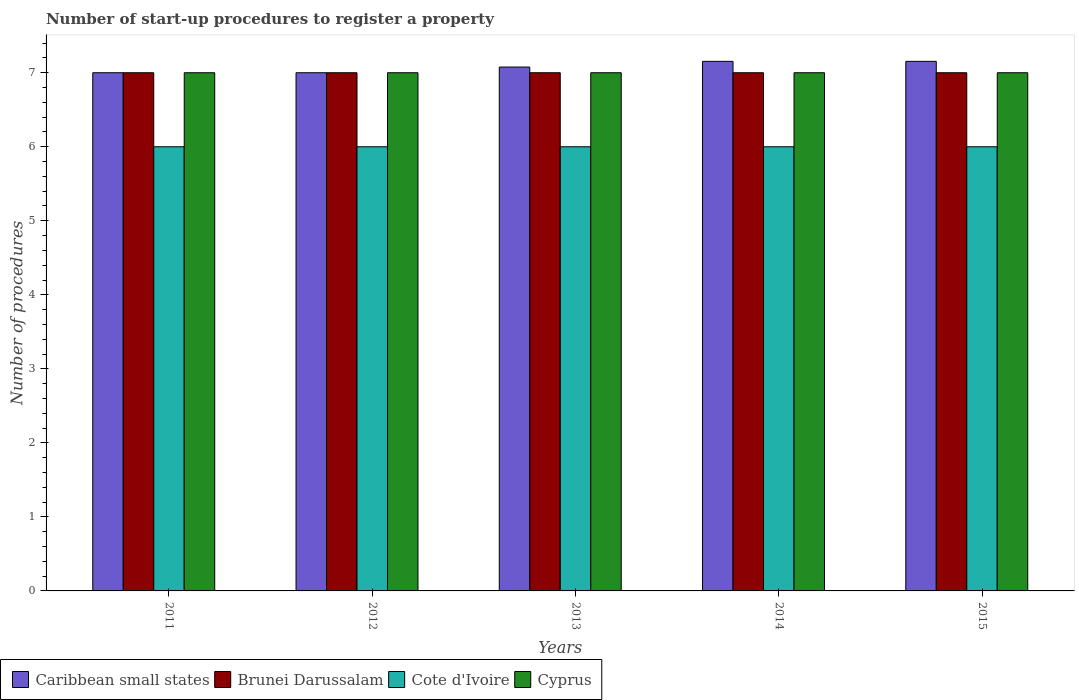How many groups of bars are there?
Ensure brevity in your answer.  5. How many bars are there on the 4th tick from the left?
Keep it short and to the point. 4. How many bars are there on the 2nd tick from the right?
Offer a terse response. 4. What is the label of the 2nd group of bars from the left?
Offer a terse response. 2012. In how many cases, is the number of bars for a given year not equal to the number of legend labels?
Your response must be concise. 0. What is the number of procedures required to register a property in Caribbean small states in 2013?
Your answer should be very brief. 7.08. Across all years, what is the minimum number of procedures required to register a property in Cote d'Ivoire?
Keep it short and to the point. 6. What is the difference between the number of procedures required to register a property in Cote d'Ivoire in 2014 and that in 2015?
Your answer should be compact. 0. In the year 2011, what is the difference between the number of procedures required to register a property in Caribbean small states and number of procedures required to register a property in Cote d'Ivoire?
Provide a succinct answer. 1. What is the ratio of the number of procedures required to register a property in Cote d'Ivoire in 2013 to that in 2014?
Provide a succinct answer. 1. Is the difference between the number of procedures required to register a property in Caribbean small states in 2014 and 2015 greater than the difference between the number of procedures required to register a property in Cote d'Ivoire in 2014 and 2015?
Your answer should be very brief. No. What is the difference between the highest and the lowest number of procedures required to register a property in Caribbean small states?
Make the answer very short. 0.15. In how many years, is the number of procedures required to register a property in Brunei Darussalam greater than the average number of procedures required to register a property in Brunei Darussalam taken over all years?
Make the answer very short. 0. Is the sum of the number of procedures required to register a property in Brunei Darussalam in 2012 and 2015 greater than the maximum number of procedures required to register a property in Cyprus across all years?
Give a very brief answer. Yes. What does the 3rd bar from the left in 2015 represents?
Your answer should be compact. Cote d'Ivoire. What does the 4th bar from the right in 2015 represents?
Your response must be concise. Caribbean small states. How many bars are there?
Make the answer very short. 20. How many years are there in the graph?
Give a very brief answer. 5. What is the difference between two consecutive major ticks on the Y-axis?
Offer a very short reply. 1. Are the values on the major ticks of Y-axis written in scientific E-notation?
Provide a succinct answer. No. Does the graph contain grids?
Provide a succinct answer. No. Where does the legend appear in the graph?
Give a very brief answer. Bottom left. What is the title of the graph?
Ensure brevity in your answer.  Number of start-up procedures to register a property. Does "Austria" appear as one of the legend labels in the graph?
Give a very brief answer. No. What is the label or title of the Y-axis?
Your response must be concise. Number of procedures. What is the Number of procedures of Brunei Darussalam in 2011?
Keep it short and to the point. 7. What is the Number of procedures in Cyprus in 2011?
Ensure brevity in your answer.  7. What is the Number of procedures of Caribbean small states in 2012?
Your answer should be compact. 7. What is the Number of procedures in Cyprus in 2012?
Keep it short and to the point. 7. What is the Number of procedures in Caribbean small states in 2013?
Offer a very short reply. 7.08. What is the Number of procedures in Brunei Darussalam in 2013?
Offer a very short reply. 7. What is the Number of procedures of Caribbean small states in 2014?
Make the answer very short. 7.15. What is the Number of procedures of Brunei Darussalam in 2014?
Provide a succinct answer. 7. What is the Number of procedures of Cyprus in 2014?
Provide a succinct answer. 7. What is the Number of procedures in Caribbean small states in 2015?
Your answer should be very brief. 7.15. What is the Number of procedures in Brunei Darussalam in 2015?
Your answer should be compact. 7. What is the Number of procedures of Cyprus in 2015?
Provide a short and direct response. 7. Across all years, what is the maximum Number of procedures in Caribbean small states?
Offer a terse response. 7.15. Across all years, what is the minimum Number of procedures of Caribbean small states?
Your answer should be compact. 7. Across all years, what is the minimum Number of procedures in Cyprus?
Provide a succinct answer. 7. What is the total Number of procedures of Caribbean small states in the graph?
Give a very brief answer. 35.38. What is the total Number of procedures in Cote d'Ivoire in the graph?
Your answer should be very brief. 30. What is the total Number of procedures of Cyprus in the graph?
Your response must be concise. 35. What is the difference between the Number of procedures in Caribbean small states in 2011 and that in 2012?
Provide a succinct answer. 0. What is the difference between the Number of procedures of Brunei Darussalam in 2011 and that in 2012?
Your answer should be very brief. 0. What is the difference between the Number of procedures of Cyprus in 2011 and that in 2012?
Provide a succinct answer. 0. What is the difference between the Number of procedures in Caribbean small states in 2011 and that in 2013?
Your answer should be compact. -0.08. What is the difference between the Number of procedures of Brunei Darussalam in 2011 and that in 2013?
Keep it short and to the point. 0. What is the difference between the Number of procedures in Cote d'Ivoire in 2011 and that in 2013?
Keep it short and to the point. 0. What is the difference between the Number of procedures in Caribbean small states in 2011 and that in 2014?
Your response must be concise. -0.15. What is the difference between the Number of procedures of Brunei Darussalam in 2011 and that in 2014?
Provide a short and direct response. 0. What is the difference between the Number of procedures in Caribbean small states in 2011 and that in 2015?
Offer a terse response. -0.15. What is the difference between the Number of procedures of Brunei Darussalam in 2011 and that in 2015?
Ensure brevity in your answer.  0. What is the difference between the Number of procedures in Cote d'Ivoire in 2011 and that in 2015?
Your response must be concise. 0. What is the difference between the Number of procedures in Caribbean small states in 2012 and that in 2013?
Offer a very short reply. -0.08. What is the difference between the Number of procedures of Caribbean small states in 2012 and that in 2014?
Your answer should be compact. -0.15. What is the difference between the Number of procedures of Brunei Darussalam in 2012 and that in 2014?
Your answer should be very brief. 0. What is the difference between the Number of procedures of Cote d'Ivoire in 2012 and that in 2014?
Your response must be concise. 0. What is the difference between the Number of procedures in Caribbean small states in 2012 and that in 2015?
Provide a short and direct response. -0.15. What is the difference between the Number of procedures in Brunei Darussalam in 2012 and that in 2015?
Offer a very short reply. 0. What is the difference between the Number of procedures of Caribbean small states in 2013 and that in 2014?
Offer a very short reply. -0.08. What is the difference between the Number of procedures in Brunei Darussalam in 2013 and that in 2014?
Give a very brief answer. 0. What is the difference between the Number of procedures in Cote d'Ivoire in 2013 and that in 2014?
Keep it short and to the point. 0. What is the difference between the Number of procedures in Cyprus in 2013 and that in 2014?
Provide a succinct answer. 0. What is the difference between the Number of procedures of Caribbean small states in 2013 and that in 2015?
Make the answer very short. -0.08. What is the difference between the Number of procedures in Cote d'Ivoire in 2014 and that in 2015?
Ensure brevity in your answer.  0. What is the difference between the Number of procedures of Caribbean small states in 2011 and the Number of procedures of Brunei Darussalam in 2012?
Ensure brevity in your answer.  0. What is the difference between the Number of procedures in Caribbean small states in 2011 and the Number of procedures in Cote d'Ivoire in 2012?
Offer a very short reply. 1. What is the difference between the Number of procedures in Caribbean small states in 2011 and the Number of procedures in Cyprus in 2012?
Your answer should be compact. 0. What is the difference between the Number of procedures of Cote d'Ivoire in 2011 and the Number of procedures of Cyprus in 2012?
Your answer should be very brief. -1. What is the difference between the Number of procedures of Caribbean small states in 2011 and the Number of procedures of Brunei Darussalam in 2013?
Offer a terse response. 0. What is the difference between the Number of procedures of Caribbean small states in 2011 and the Number of procedures of Cote d'Ivoire in 2013?
Ensure brevity in your answer.  1. What is the difference between the Number of procedures of Brunei Darussalam in 2011 and the Number of procedures of Cyprus in 2013?
Offer a terse response. 0. What is the difference between the Number of procedures of Cote d'Ivoire in 2011 and the Number of procedures of Cyprus in 2013?
Provide a short and direct response. -1. What is the difference between the Number of procedures in Caribbean small states in 2011 and the Number of procedures in Brunei Darussalam in 2014?
Ensure brevity in your answer.  0. What is the difference between the Number of procedures in Brunei Darussalam in 2011 and the Number of procedures in Cote d'Ivoire in 2014?
Your answer should be compact. 1. What is the difference between the Number of procedures in Brunei Darussalam in 2011 and the Number of procedures in Cyprus in 2014?
Provide a short and direct response. 0. What is the difference between the Number of procedures of Caribbean small states in 2011 and the Number of procedures of Brunei Darussalam in 2015?
Your answer should be compact. 0. What is the difference between the Number of procedures of Caribbean small states in 2011 and the Number of procedures of Cote d'Ivoire in 2015?
Make the answer very short. 1. What is the difference between the Number of procedures in Caribbean small states in 2011 and the Number of procedures in Cyprus in 2015?
Offer a terse response. 0. What is the difference between the Number of procedures of Cote d'Ivoire in 2011 and the Number of procedures of Cyprus in 2015?
Your answer should be compact. -1. What is the difference between the Number of procedures in Caribbean small states in 2012 and the Number of procedures in Brunei Darussalam in 2013?
Make the answer very short. 0. What is the difference between the Number of procedures of Caribbean small states in 2012 and the Number of procedures of Cote d'Ivoire in 2013?
Keep it short and to the point. 1. What is the difference between the Number of procedures in Caribbean small states in 2012 and the Number of procedures in Cyprus in 2013?
Your answer should be compact. 0. What is the difference between the Number of procedures of Brunei Darussalam in 2012 and the Number of procedures of Cyprus in 2013?
Give a very brief answer. 0. What is the difference between the Number of procedures in Cote d'Ivoire in 2012 and the Number of procedures in Cyprus in 2013?
Your answer should be very brief. -1. What is the difference between the Number of procedures in Caribbean small states in 2012 and the Number of procedures in Brunei Darussalam in 2014?
Offer a terse response. 0. What is the difference between the Number of procedures of Brunei Darussalam in 2012 and the Number of procedures of Cyprus in 2014?
Your response must be concise. 0. What is the difference between the Number of procedures of Cote d'Ivoire in 2012 and the Number of procedures of Cyprus in 2014?
Give a very brief answer. -1. What is the difference between the Number of procedures in Caribbean small states in 2012 and the Number of procedures in Cyprus in 2015?
Keep it short and to the point. 0. What is the difference between the Number of procedures in Cote d'Ivoire in 2012 and the Number of procedures in Cyprus in 2015?
Your response must be concise. -1. What is the difference between the Number of procedures of Caribbean small states in 2013 and the Number of procedures of Brunei Darussalam in 2014?
Give a very brief answer. 0.08. What is the difference between the Number of procedures in Caribbean small states in 2013 and the Number of procedures in Cyprus in 2014?
Make the answer very short. 0.08. What is the difference between the Number of procedures in Brunei Darussalam in 2013 and the Number of procedures in Cote d'Ivoire in 2014?
Your response must be concise. 1. What is the difference between the Number of procedures in Caribbean small states in 2013 and the Number of procedures in Brunei Darussalam in 2015?
Ensure brevity in your answer.  0.08. What is the difference between the Number of procedures in Caribbean small states in 2013 and the Number of procedures in Cyprus in 2015?
Give a very brief answer. 0.08. What is the difference between the Number of procedures in Brunei Darussalam in 2013 and the Number of procedures in Cote d'Ivoire in 2015?
Make the answer very short. 1. What is the difference between the Number of procedures of Caribbean small states in 2014 and the Number of procedures of Brunei Darussalam in 2015?
Your answer should be compact. 0.15. What is the difference between the Number of procedures of Caribbean small states in 2014 and the Number of procedures of Cote d'Ivoire in 2015?
Provide a short and direct response. 1.15. What is the difference between the Number of procedures in Caribbean small states in 2014 and the Number of procedures in Cyprus in 2015?
Ensure brevity in your answer.  0.15. What is the average Number of procedures of Caribbean small states per year?
Provide a short and direct response. 7.08. In the year 2011, what is the difference between the Number of procedures in Caribbean small states and Number of procedures in Cote d'Ivoire?
Make the answer very short. 1. In the year 2011, what is the difference between the Number of procedures in Brunei Darussalam and Number of procedures in Cote d'Ivoire?
Provide a short and direct response. 1. In the year 2011, what is the difference between the Number of procedures in Brunei Darussalam and Number of procedures in Cyprus?
Give a very brief answer. 0. In the year 2011, what is the difference between the Number of procedures in Cote d'Ivoire and Number of procedures in Cyprus?
Your answer should be very brief. -1. In the year 2012, what is the difference between the Number of procedures of Caribbean small states and Number of procedures of Brunei Darussalam?
Ensure brevity in your answer.  0. In the year 2012, what is the difference between the Number of procedures of Caribbean small states and Number of procedures of Cote d'Ivoire?
Provide a succinct answer. 1. In the year 2012, what is the difference between the Number of procedures of Brunei Darussalam and Number of procedures of Cote d'Ivoire?
Ensure brevity in your answer.  1. In the year 2012, what is the difference between the Number of procedures in Cote d'Ivoire and Number of procedures in Cyprus?
Provide a succinct answer. -1. In the year 2013, what is the difference between the Number of procedures in Caribbean small states and Number of procedures in Brunei Darussalam?
Give a very brief answer. 0.08. In the year 2013, what is the difference between the Number of procedures of Caribbean small states and Number of procedures of Cyprus?
Your answer should be very brief. 0.08. In the year 2013, what is the difference between the Number of procedures in Brunei Darussalam and Number of procedures in Cyprus?
Provide a succinct answer. 0. In the year 2014, what is the difference between the Number of procedures of Caribbean small states and Number of procedures of Brunei Darussalam?
Give a very brief answer. 0.15. In the year 2014, what is the difference between the Number of procedures in Caribbean small states and Number of procedures in Cote d'Ivoire?
Keep it short and to the point. 1.15. In the year 2014, what is the difference between the Number of procedures of Caribbean small states and Number of procedures of Cyprus?
Your answer should be very brief. 0.15. In the year 2014, what is the difference between the Number of procedures in Brunei Darussalam and Number of procedures in Cote d'Ivoire?
Your answer should be compact. 1. In the year 2014, what is the difference between the Number of procedures of Cote d'Ivoire and Number of procedures of Cyprus?
Make the answer very short. -1. In the year 2015, what is the difference between the Number of procedures in Caribbean small states and Number of procedures in Brunei Darussalam?
Your answer should be compact. 0.15. In the year 2015, what is the difference between the Number of procedures in Caribbean small states and Number of procedures in Cote d'Ivoire?
Your response must be concise. 1.15. In the year 2015, what is the difference between the Number of procedures in Caribbean small states and Number of procedures in Cyprus?
Make the answer very short. 0.15. In the year 2015, what is the difference between the Number of procedures in Brunei Darussalam and Number of procedures in Cyprus?
Give a very brief answer. 0. In the year 2015, what is the difference between the Number of procedures of Cote d'Ivoire and Number of procedures of Cyprus?
Make the answer very short. -1. What is the ratio of the Number of procedures of Caribbean small states in 2011 to that in 2012?
Offer a very short reply. 1. What is the ratio of the Number of procedures in Brunei Darussalam in 2011 to that in 2012?
Offer a terse response. 1. What is the ratio of the Number of procedures in Cyprus in 2011 to that in 2013?
Offer a very short reply. 1. What is the ratio of the Number of procedures in Caribbean small states in 2011 to that in 2014?
Make the answer very short. 0.98. What is the ratio of the Number of procedures of Cote d'Ivoire in 2011 to that in 2014?
Provide a short and direct response. 1. What is the ratio of the Number of procedures of Cyprus in 2011 to that in 2014?
Provide a succinct answer. 1. What is the ratio of the Number of procedures of Caribbean small states in 2011 to that in 2015?
Give a very brief answer. 0.98. What is the ratio of the Number of procedures of Brunei Darussalam in 2011 to that in 2015?
Make the answer very short. 1. What is the ratio of the Number of procedures of Cote d'Ivoire in 2011 to that in 2015?
Your answer should be very brief. 1. What is the ratio of the Number of procedures in Caribbean small states in 2012 to that in 2013?
Provide a succinct answer. 0.99. What is the ratio of the Number of procedures of Caribbean small states in 2012 to that in 2014?
Provide a succinct answer. 0.98. What is the ratio of the Number of procedures of Brunei Darussalam in 2012 to that in 2014?
Keep it short and to the point. 1. What is the ratio of the Number of procedures of Cyprus in 2012 to that in 2014?
Offer a terse response. 1. What is the ratio of the Number of procedures in Caribbean small states in 2012 to that in 2015?
Offer a terse response. 0.98. What is the ratio of the Number of procedures in Cote d'Ivoire in 2012 to that in 2015?
Make the answer very short. 1. What is the ratio of the Number of procedures in Brunei Darussalam in 2013 to that in 2014?
Your answer should be compact. 1. What is the ratio of the Number of procedures in Cote d'Ivoire in 2013 to that in 2014?
Provide a short and direct response. 1. What is the ratio of the Number of procedures of Cyprus in 2013 to that in 2014?
Make the answer very short. 1. What is the ratio of the Number of procedures in Cyprus in 2013 to that in 2015?
Your answer should be very brief. 1. What is the ratio of the Number of procedures of Caribbean small states in 2014 to that in 2015?
Keep it short and to the point. 1. What is the ratio of the Number of procedures of Brunei Darussalam in 2014 to that in 2015?
Keep it short and to the point. 1. What is the ratio of the Number of procedures in Cote d'Ivoire in 2014 to that in 2015?
Offer a very short reply. 1. What is the difference between the highest and the second highest Number of procedures in Brunei Darussalam?
Ensure brevity in your answer.  0. What is the difference between the highest and the second highest Number of procedures in Cote d'Ivoire?
Keep it short and to the point. 0. What is the difference between the highest and the lowest Number of procedures in Caribbean small states?
Give a very brief answer. 0.15. 